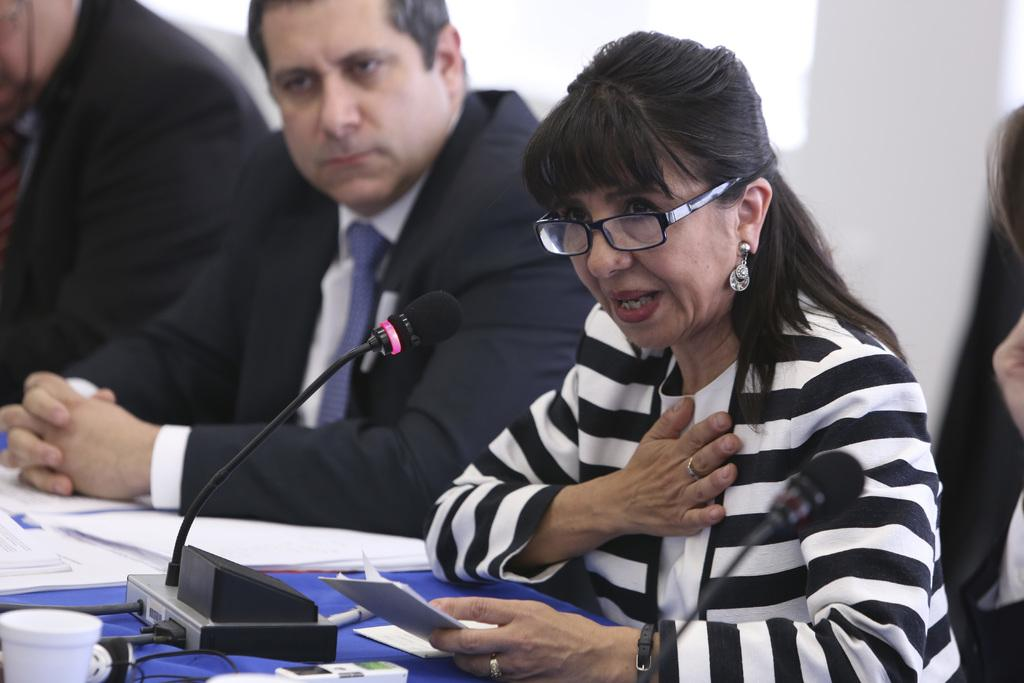Who is the main subject in the image? There is a lady in the image. Where is the lady positioned in the image? The lady is sitting on the right side of the image. Are there any other people visible in the image? Yes, there are other people behind the lady. What object is in front of the lady? There is a microphone in front of the lady. What type of shade does the lady's aunt bring during the voyage in the image? There is no mention of an aunt, voyage, or shade in the image. 